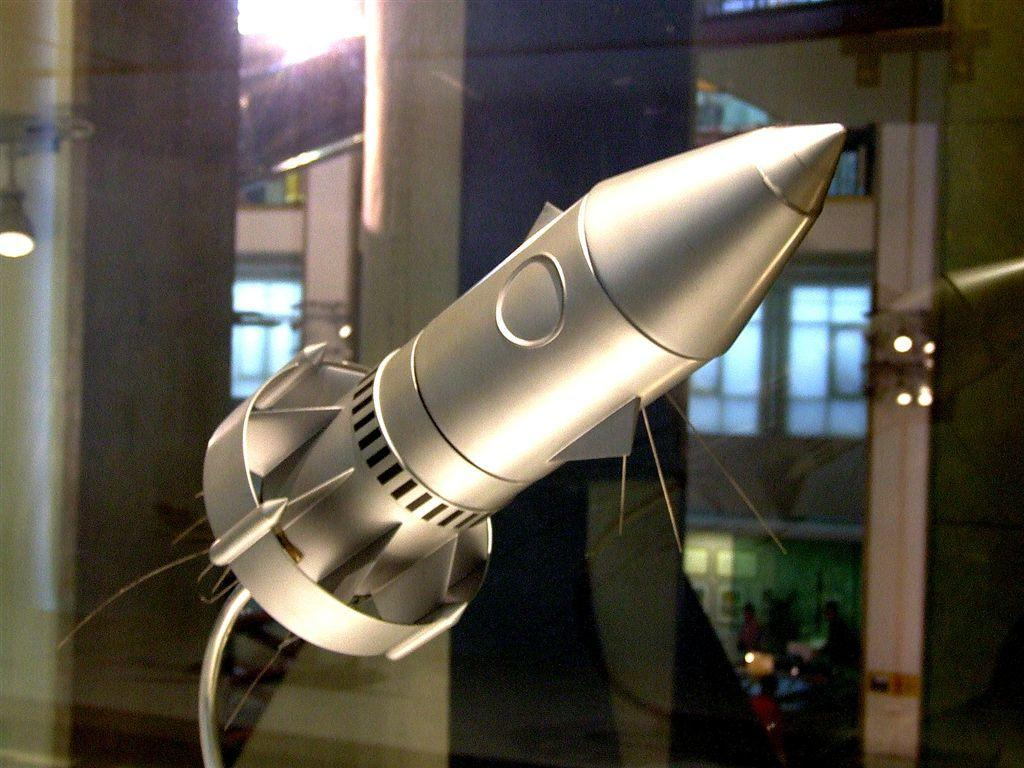What type of object is in the image and placed in a glass container? There is a metal object in the image, and it is placed in a glass container. What can be seen in the background of the image? In the background of the image, there are pillars and lights attached to the ceiling. How does the metal object express anger in the image? The metal object does not express anger in the image, as it is an inanimate object and cannot display emotions. 